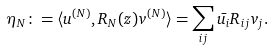Convert formula to latex. <formula><loc_0><loc_0><loc_500><loc_500>\eta _ { N } \colon = \langle u ^ { ( N ) } , R _ { N } ( z ) v ^ { ( N ) } \rangle = \sum _ { i j } \bar { u _ { i } } R _ { i j } v _ { j } .</formula> 